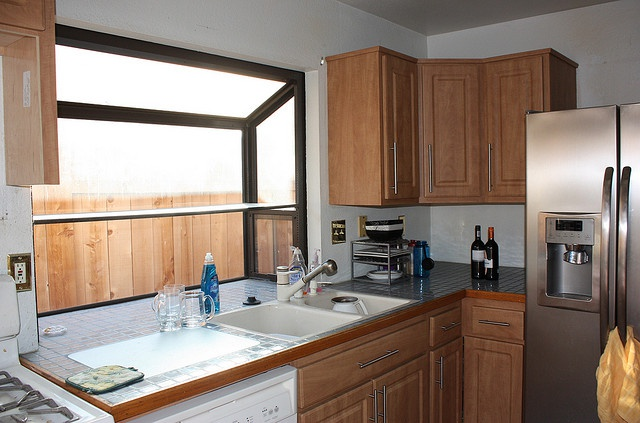Describe the objects in this image and their specific colors. I can see refrigerator in maroon, black, gray, lightgray, and darkgray tones, oven in maroon, darkgray, gray, and lightgray tones, sink in maroon, darkgray, and lightgray tones, cup in maroon, lightgray, darkgray, and lightblue tones, and cup in maroon, lightgray, and darkgray tones in this image. 